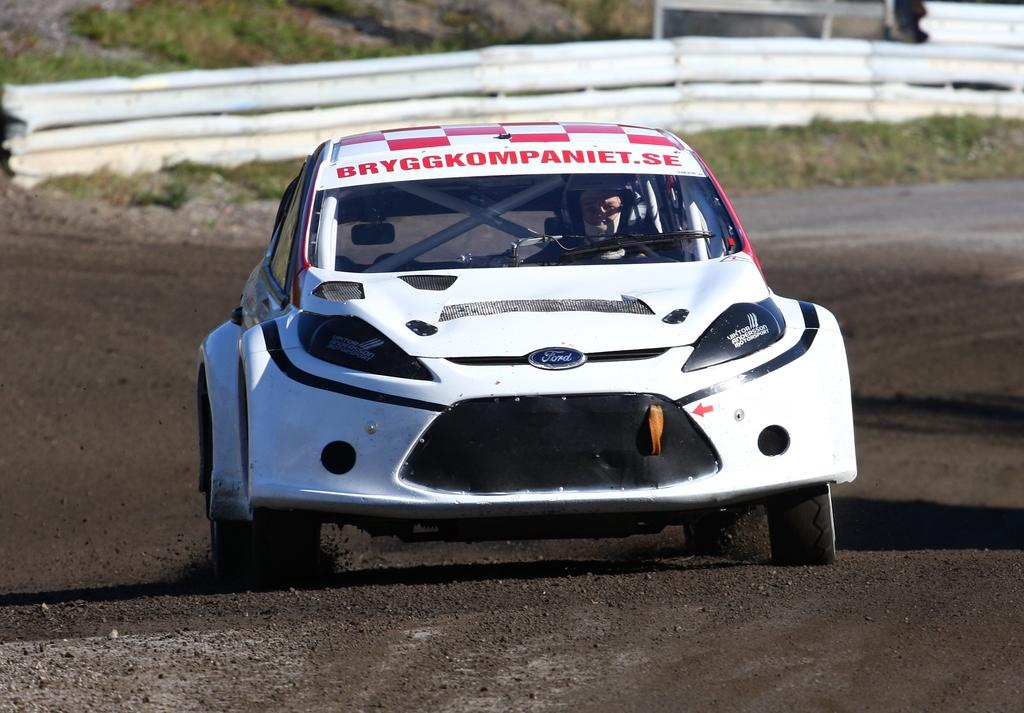What is the main subject of the image? The main subject of the image is a car on the road. Can you describe the car's occupant? There is a person sitting in the car. What is located near the car in the image? There is a fence on the grassland in the image. What type of rub is being used to clean the car in the image? There is no rub visible in the image, and the car is not being cleaned. 